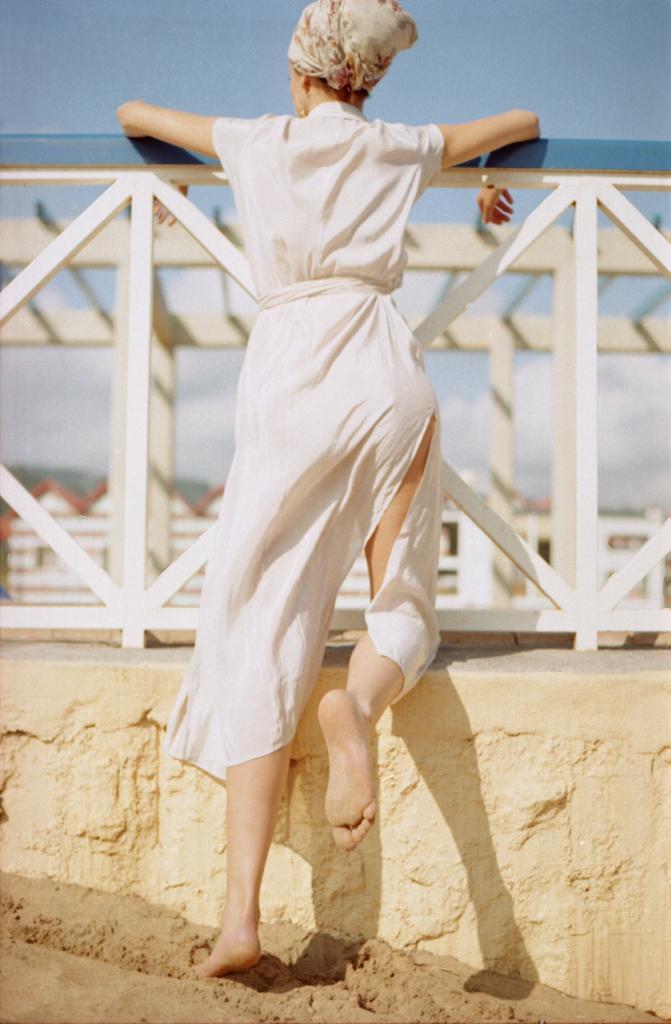Describe this image in one or two sentences. In this image we can see a woman standing beside a fence. We can also see a wall and sand. On the backside we can see some houses, a roof with stone pillars and the sky. 